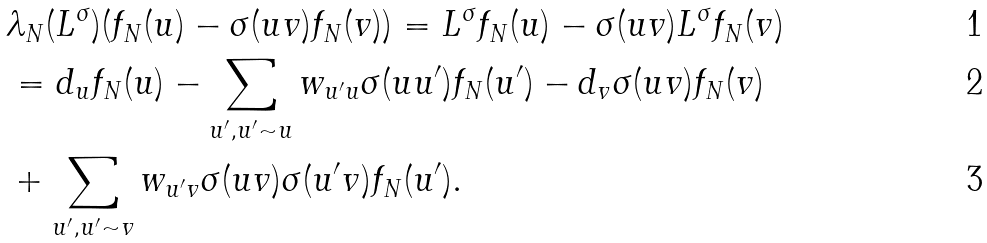Convert formula to latex. <formula><loc_0><loc_0><loc_500><loc_500>& \lambda _ { N } ( L ^ { \sigma } ) ( f _ { N } ( u ) - \sigma ( u v ) f _ { N } ( v ) ) = L ^ { \sigma } f _ { N } ( u ) - \sigma ( u v ) L ^ { \sigma } f _ { N } ( v ) \\ & = d _ { u } f _ { N } ( u ) - \sum _ { u ^ { \prime } , u ^ { \prime } \sim u } w _ { u ^ { \prime } u } \sigma ( u u ^ { \prime } ) f _ { N } ( u ^ { \prime } ) - d _ { v } \sigma ( u v ) f _ { N } ( v ) \\ & + \sum _ { u ^ { \prime } , u ^ { \prime } \sim v } w _ { u ^ { \prime } v } \sigma ( u v ) \sigma ( u ^ { \prime } v ) f _ { N } ( u ^ { \prime } ) .</formula> 